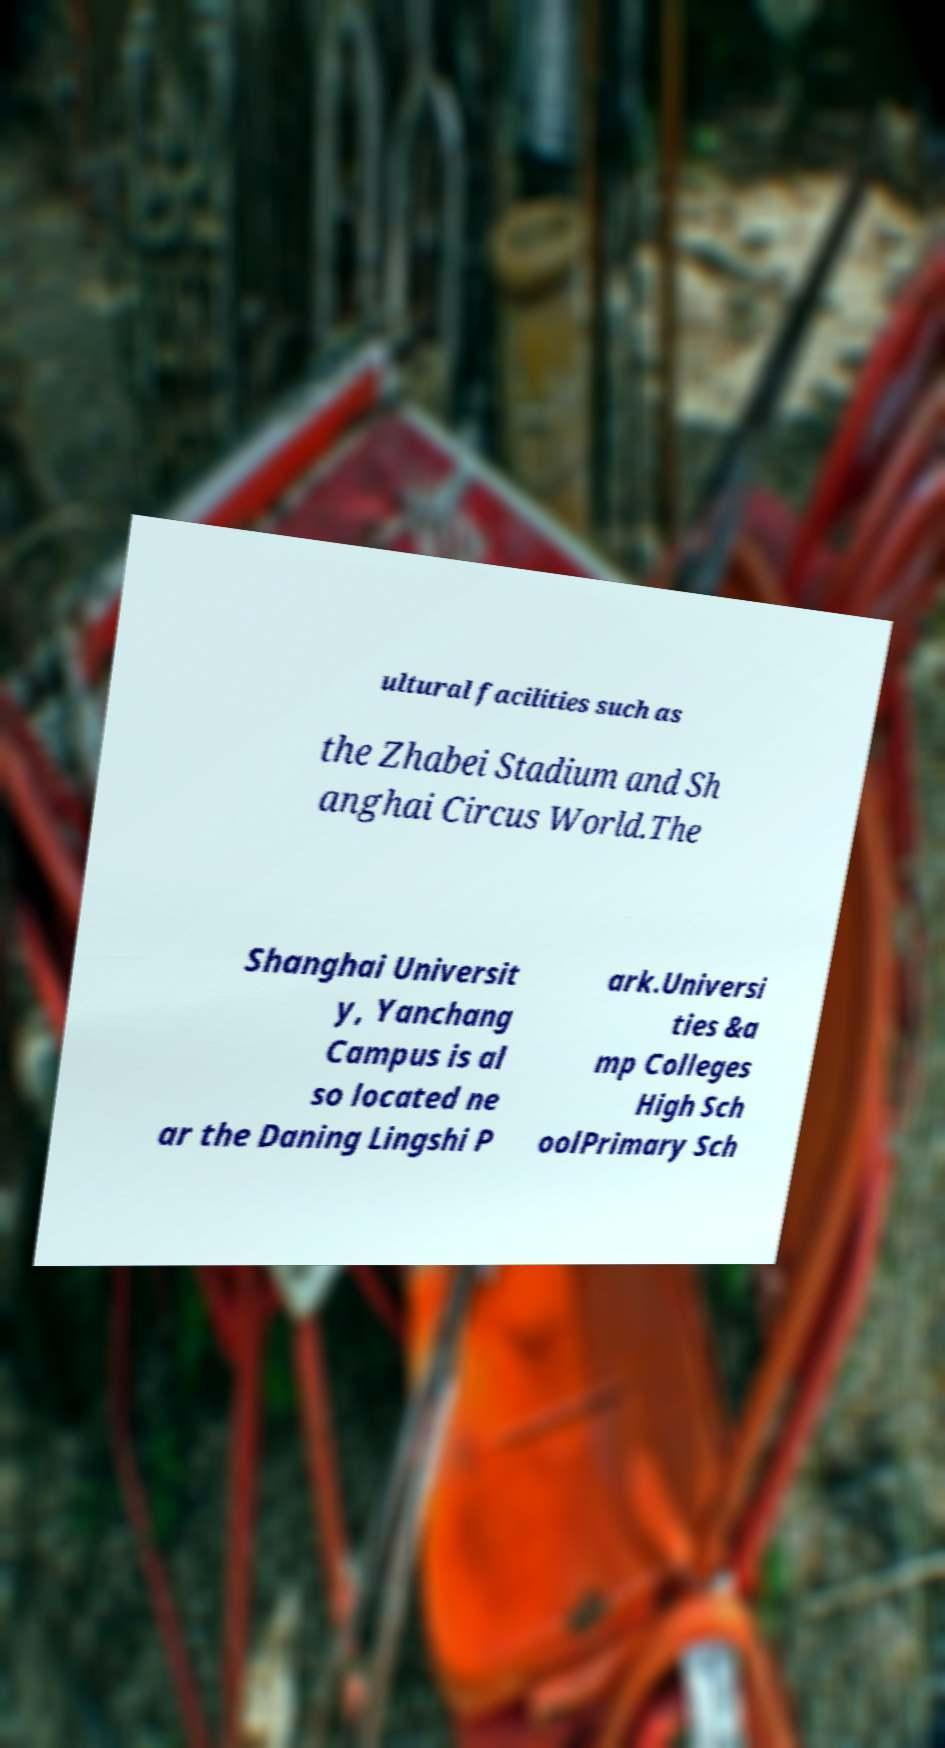Can you accurately transcribe the text from the provided image for me? ultural facilities such as the Zhabei Stadium and Sh anghai Circus World.The Shanghai Universit y, Yanchang Campus is al so located ne ar the Daning Lingshi P ark.Universi ties &a mp Colleges High Sch oolPrimary Sch 